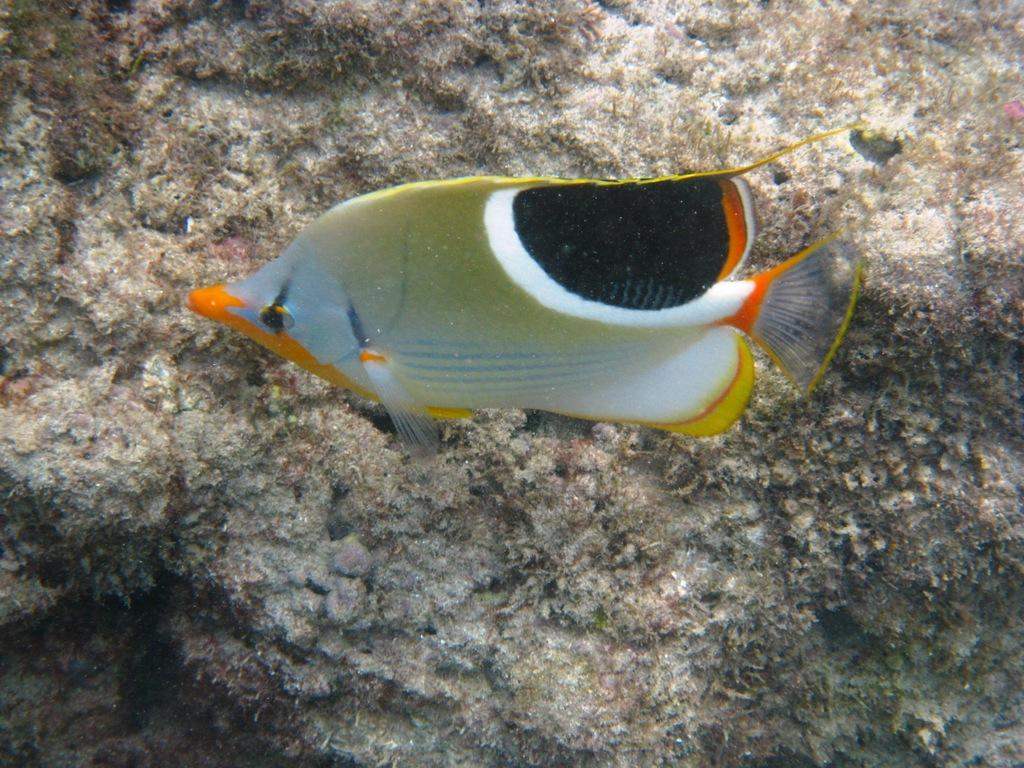What is located in the foreground of the image? There is a fish under the water in the foreground. What can be seen in the background of the image? There appears to be rocks in the background area. What type of meal is being prepared near the rocks in the image? There is no indication of a meal or any cooking activity in the image; it primarily features a fish under the water and rocks in the background. 